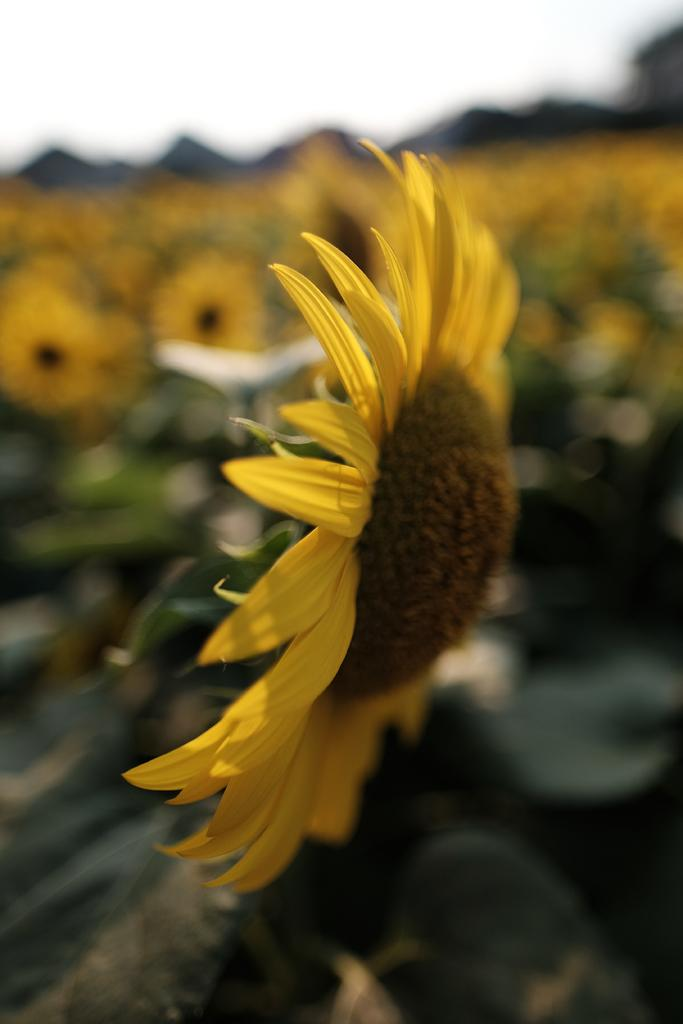What type of plant is featured in the image? There is a sunflower in the image. Can you describe the background of the image? The background of the sunflower is blurred. How many boys are present in the image? There are no boys present in the image; it features a sunflower with a blurred background. What type of wound can be seen on the sunflower in the image? There is no wound present on the sunflower in the image. 